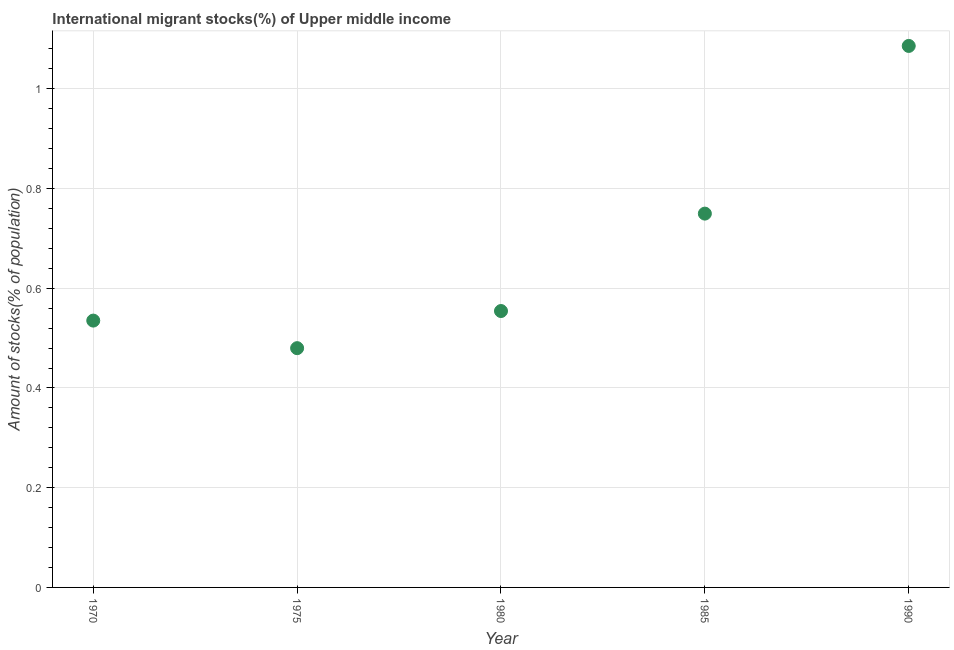What is the number of international migrant stocks in 1985?
Ensure brevity in your answer.  0.75. Across all years, what is the maximum number of international migrant stocks?
Keep it short and to the point. 1.09. Across all years, what is the minimum number of international migrant stocks?
Provide a succinct answer. 0.48. In which year was the number of international migrant stocks maximum?
Your answer should be compact. 1990. In which year was the number of international migrant stocks minimum?
Your answer should be very brief. 1975. What is the sum of the number of international migrant stocks?
Your answer should be compact. 3.4. What is the difference between the number of international migrant stocks in 1970 and 1985?
Your response must be concise. -0.21. What is the average number of international migrant stocks per year?
Your answer should be very brief. 0.68. What is the median number of international migrant stocks?
Offer a very short reply. 0.55. What is the ratio of the number of international migrant stocks in 1970 to that in 1990?
Ensure brevity in your answer.  0.49. Is the number of international migrant stocks in 1980 less than that in 1990?
Keep it short and to the point. Yes. Is the difference between the number of international migrant stocks in 1975 and 1980 greater than the difference between any two years?
Make the answer very short. No. What is the difference between the highest and the second highest number of international migrant stocks?
Offer a terse response. 0.34. Is the sum of the number of international migrant stocks in 1975 and 1980 greater than the maximum number of international migrant stocks across all years?
Your answer should be very brief. No. What is the difference between the highest and the lowest number of international migrant stocks?
Your answer should be compact. 0.61. Does the number of international migrant stocks monotonically increase over the years?
Make the answer very short. No. How many dotlines are there?
Your answer should be compact. 1. Are the values on the major ticks of Y-axis written in scientific E-notation?
Offer a terse response. No. Does the graph contain any zero values?
Ensure brevity in your answer.  No. What is the title of the graph?
Offer a terse response. International migrant stocks(%) of Upper middle income. What is the label or title of the Y-axis?
Provide a short and direct response. Amount of stocks(% of population). What is the Amount of stocks(% of population) in 1970?
Ensure brevity in your answer.  0.54. What is the Amount of stocks(% of population) in 1975?
Make the answer very short. 0.48. What is the Amount of stocks(% of population) in 1980?
Provide a succinct answer. 0.55. What is the Amount of stocks(% of population) in 1985?
Offer a very short reply. 0.75. What is the Amount of stocks(% of population) in 1990?
Give a very brief answer. 1.09. What is the difference between the Amount of stocks(% of population) in 1970 and 1975?
Your response must be concise. 0.06. What is the difference between the Amount of stocks(% of population) in 1970 and 1980?
Keep it short and to the point. -0.02. What is the difference between the Amount of stocks(% of population) in 1970 and 1985?
Your answer should be compact. -0.21. What is the difference between the Amount of stocks(% of population) in 1970 and 1990?
Your response must be concise. -0.55. What is the difference between the Amount of stocks(% of population) in 1975 and 1980?
Offer a terse response. -0.07. What is the difference between the Amount of stocks(% of population) in 1975 and 1985?
Offer a terse response. -0.27. What is the difference between the Amount of stocks(% of population) in 1975 and 1990?
Ensure brevity in your answer.  -0.61. What is the difference between the Amount of stocks(% of population) in 1980 and 1985?
Offer a very short reply. -0.2. What is the difference between the Amount of stocks(% of population) in 1980 and 1990?
Offer a terse response. -0.53. What is the difference between the Amount of stocks(% of population) in 1985 and 1990?
Offer a terse response. -0.34. What is the ratio of the Amount of stocks(% of population) in 1970 to that in 1975?
Offer a very short reply. 1.11. What is the ratio of the Amount of stocks(% of population) in 1970 to that in 1985?
Provide a short and direct response. 0.71. What is the ratio of the Amount of stocks(% of population) in 1970 to that in 1990?
Make the answer very short. 0.49. What is the ratio of the Amount of stocks(% of population) in 1975 to that in 1980?
Make the answer very short. 0.87. What is the ratio of the Amount of stocks(% of population) in 1975 to that in 1985?
Provide a succinct answer. 0.64. What is the ratio of the Amount of stocks(% of population) in 1975 to that in 1990?
Offer a terse response. 0.44. What is the ratio of the Amount of stocks(% of population) in 1980 to that in 1985?
Provide a succinct answer. 0.74. What is the ratio of the Amount of stocks(% of population) in 1980 to that in 1990?
Provide a succinct answer. 0.51. What is the ratio of the Amount of stocks(% of population) in 1985 to that in 1990?
Your answer should be very brief. 0.69. 